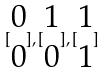<formula> <loc_0><loc_0><loc_500><loc_500>[ \begin{matrix} 0 \\ 0 \end{matrix} ] , [ \begin{matrix} 1 \\ 0 \end{matrix} ] , [ \begin{matrix} 1 \\ 1 \end{matrix} ]</formula> 